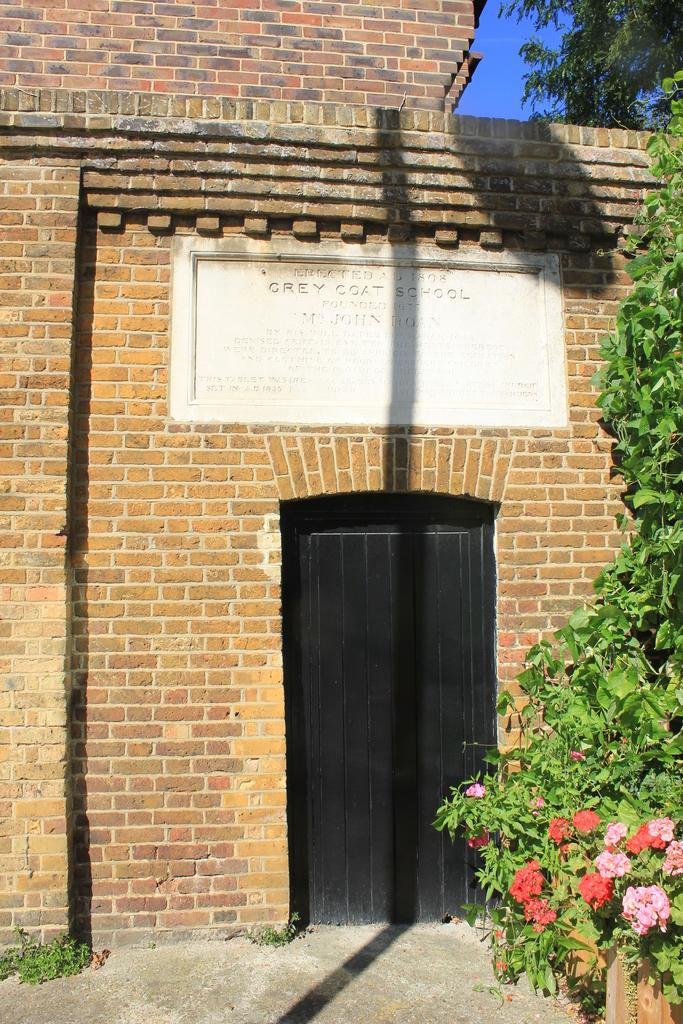What is on the wall in the image? There is a board and a door on the wall in the image. What type of vegetation can be seen in the image? There are trees and plants with flowers in the image. What is visible in the background of the image? The sky is visible in the background of the image. What type of knowledge is being shared in the image? There is no indication of knowledge being shared in the image; it features a wall with a board and a door, trees, plants with flowers, and a visible sky. Can you see a carriage in the image? There is no carriage present in the image. 